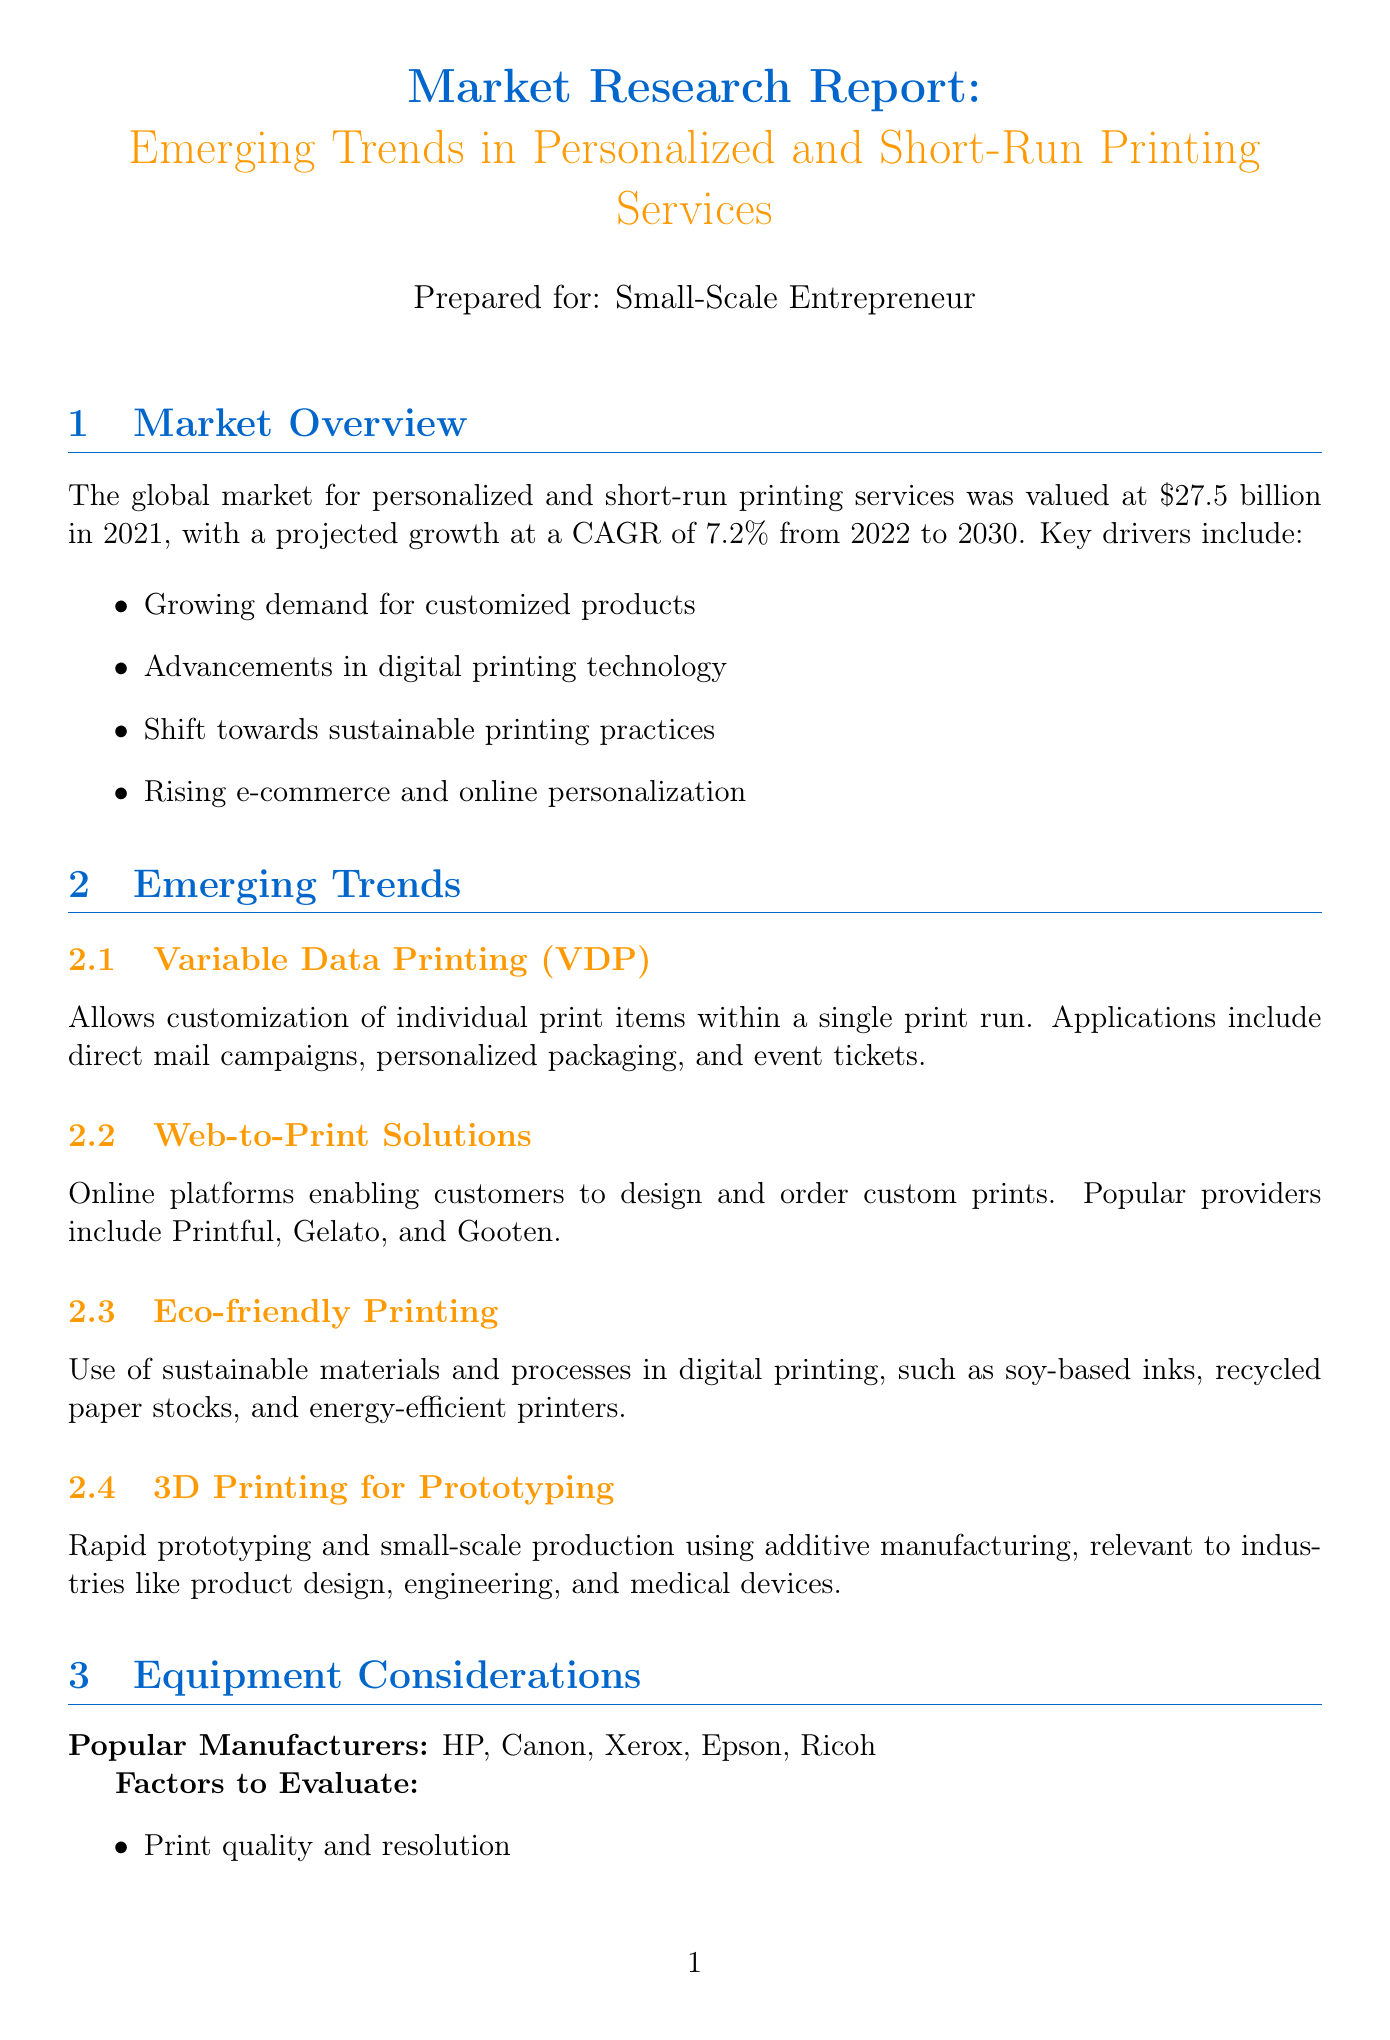What was the global market size in 2021? The document states that the global market was valued at $27.5 billion in 2021.
Answer: $27.5 billion What is the projected CAGR from 2022 to 2030? The report mentions a projected CAGR of 7.2% from 2022 to 2030.
Answer: 7.2% Name one application of Variable Data Printing (VDP). One application listed is direct mail campaigns in the report.
Answer: Direct mail campaigns What are two popular manufacturers of digital printing equipment? The document lists HP and Canon as popular manufacturers of digital printing equipment.
Answer: HP, Canon What is one benefit of short-run printing for small businesses? One benefit mentioned is reduced inventory costs.
Answer: Reduced inventory costs What is the entry-level digital press cost range? The document specifies that the cost range for entry-level digital press is $50,000 - $100,000.
Answer: $50,000 - $100,000 Which sector can benefit from custom packaging? The report indicates that e-commerce brands can benefit from custom packaging.
Answer: E-commerce brands What is one challenge mentioned in the document? The report lists keeping up with rapidly evolving technology as a challenge.
Answer: Keeping up with rapidly evolving technology 